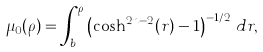Convert formula to latex. <formula><loc_0><loc_0><loc_500><loc_500>\mu _ { 0 } ( \rho ) = \int _ { b } ^ { \rho } \left ( \cosh ^ { 2 n - 2 } ( r ) - 1 \right ) ^ { - 1 / 2 } \, d r ,</formula> 